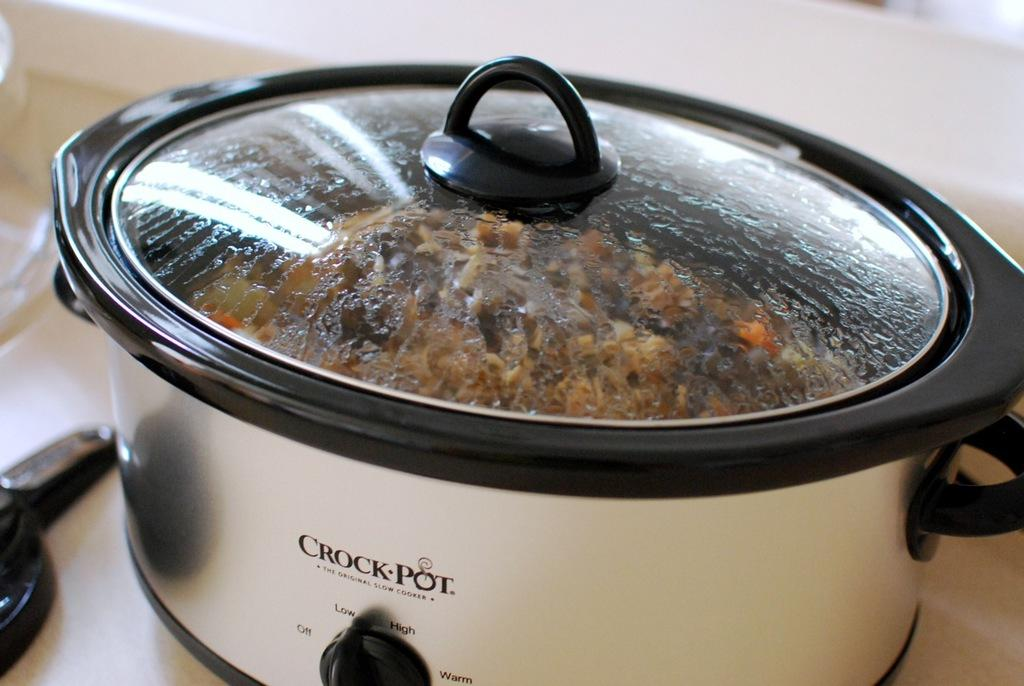<image>
Write a terse but informative summary of the picture. A crock pot is currently in use and cooking food. 